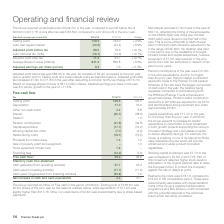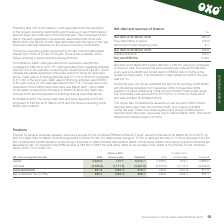According to Premier Foods Plc's financial document, What is the trading profit in 2018/19? According to the financial document, 128.5 (in millions). The relevant text states: "share (£m) 2018/19 2017/18 Change Trading profit 128.5 123.0 +4.5% Less: Net regular interest (40.5) (44.4) +8.9%..." Also, What is the trading profit in 2017/18? According to the financial document, 123.0 (in millions). The relevant text states: "(£m) 2018/19 2017/18 Change Trading profit 128.5 123.0 +4.5% Less: Net regular interest (40.5) (44.4) +8.9%..." Also, What is the depreciation in 2017/18? According to the financial document, 16.6 (in millions). The relevant text states: "7/18 Trading profit 128.5 123.0 Depreciation 17.0 16.6 Other non-cash items 2.4 2.8 Interest (30.1) (38.0) Taxation – 1.0 Pension contributions (41.9) (39..." Also, can you calculate: What was the change in the trading profit from 2017/18 to 2018/19? Based on the calculation: 128.5 - 123.0, the result is 5.5 (in millions). This is based on the information: "share (£m) 2018/19 2017/18 Change Trading profit 128.5 123.0 +4.5% Less: Net regular interest (40.5) (44.4) +8.9% (£m) 2018/19 2017/18 Change Trading profit 128.5 123.0 +4.5% Less: Net regular interes..." The key data points involved are: 123.0, 128.5. Also, can you calculate: What was the average depreciation for 2017/18 and 2018/19? To answer this question, I need to perform calculations using the financial data. The calculation is: (17.0 + 16.6) / 2, which equals 16.8 (in millions). This is based on the information: "9 2017/18 Trading profit 128.5 123.0 Depreciation 17.0 16.6 Other non-cash items 2.4 2.8 Interest (30.1) (38.0) Taxation – 1.0 Pension contributions (41.9 7/18 Trading profit 128.5 123.0 Depreciation ..." The key data points involved are: 16.6, 17.0. Also, can you calculate: What is the average other non-cash items for 2017/18 and 2018/19? To answer this question, I need to perform calculations using the financial data. The calculation is: (2.4 + 2.8) / 2 , which equals 2.6 (in millions). This is based on the information: "0 Depreciation 17.0 16.6 Other non-cash items 2.4 2.8 Interest (30.1) (38.0) Taxation – 1.0 Pension contributions (41.9) (39.8) Capital expenditure (17.7 123.0 Depreciation 17.0 16.6 Other non-cash it..." The key data points involved are: 2.4, 2.8. 